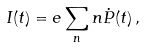<formula> <loc_0><loc_0><loc_500><loc_500>I ( t ) = e \sum _ { n } n \dot { P } ( t ) \, ,</formula> 